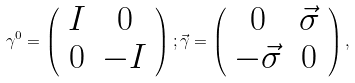Convert formula to latex. <formula><loc_0><loc_0><loc_500><loc_500>\gamma ^ { 0 } = \left ( \begin{array} { c c } I & 0 \\ 0 & - I \end{array} \right ) ; \vec { \gamma } = \left ( \begin{array} { c c } 0 & \vec { \sigma } \\ - \vec { \sigma } & 0 \end{array} \right ) ,</formula> 